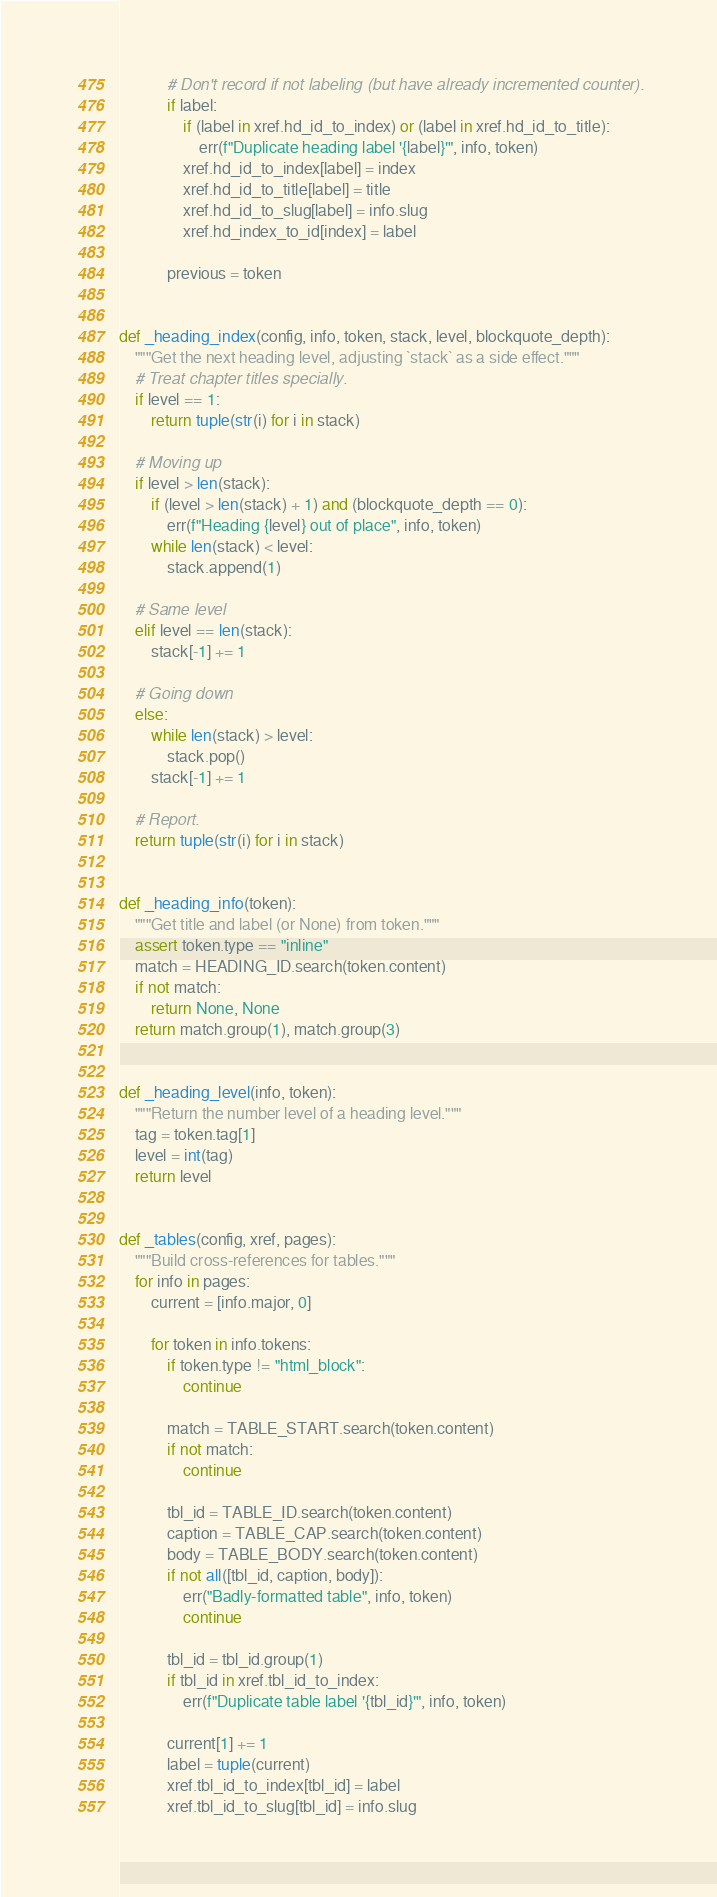Convert code to text. <code><loc_0><loc_0><loc_500><loc_500><_Python_>            # Don't record if not labeling (but have already incremented counter).
            if label:
                if (label in xref.hd_id_to_index) or (label in xref.hd_id_to_title):
                    err(f"Duplicate heading label '{label}'", info, token)
                xref.hd_id_to_index[label] = index
                xref.hd_id_to_title[label] = title
                xref.hd_id_to_slug[label] = info.slug
                xref.hd_index_to_id[index] = label

            previous = token


def _heading_index(config, info, token, stack, level, blockquote_depth):
    """Get the next heading level, adjusting `stack` as a side effect."""
    # Treat chapter titles specially.
    if level == 1:
        return tuple(str(i) for i in stack)

    # Moving up
    if level > len(stack):
        if (level > len(stack) + 1) and (blockquote_depth == 0):
            err(f"Heading {level} out of place", info, token)
        while len(stack) < level:
            stack.append(1)

    # Same level
    elif level == len(stack):
        stack[-1] += 1

    # Going down
    else:
        while len(stack) > level:
            stack.pop()
        stack[-1] += 1

    # Report.
    return tuple(str(i) for i in stack)


def _heading_info(token):
    """Get title and label (or None) from token."""
    assert token.type == "inline"
    match = HEADING_ID.search(token.content)
    if not match:
        return None, None
    return match.group(1), match.group(3)


def _heading_level(info, token):
    """Return the number level of a heading level."""
    tag = token.tag[1]
    level = int(tag)
    return level


def _tables(config, xref, pages):
    """Build cross-references for tables."""
    for info in pages:
        current = [info.major, 0]

        for token in info.tokens:
            if token.type != "html_block":
                continue

            match = TABLE_START.search(token.content)
            if not match:
                continue

            tbl_id = TABLE_ID.search(token.content)
            caption = TABLE_CAP.search(token.content)
            body = TABLE_BODY.search(token.content)
            if not all([tbl_id, caption, body]):
                err("Badly-formatted table", info, token)
                continue

            tbl_id = tbl_id.group(1)
            if tbl_id in xref.tbl_id_to_index:
                err(f"Duplicate table label '{tbl_id}'", info, token)

            current[1] += 1
            label = tuple(current)
            xref.tbl_id_to_index[tbl_id] = label
            xref.tbl_id_to_slug[tbl_id] = info.slug
</code> 